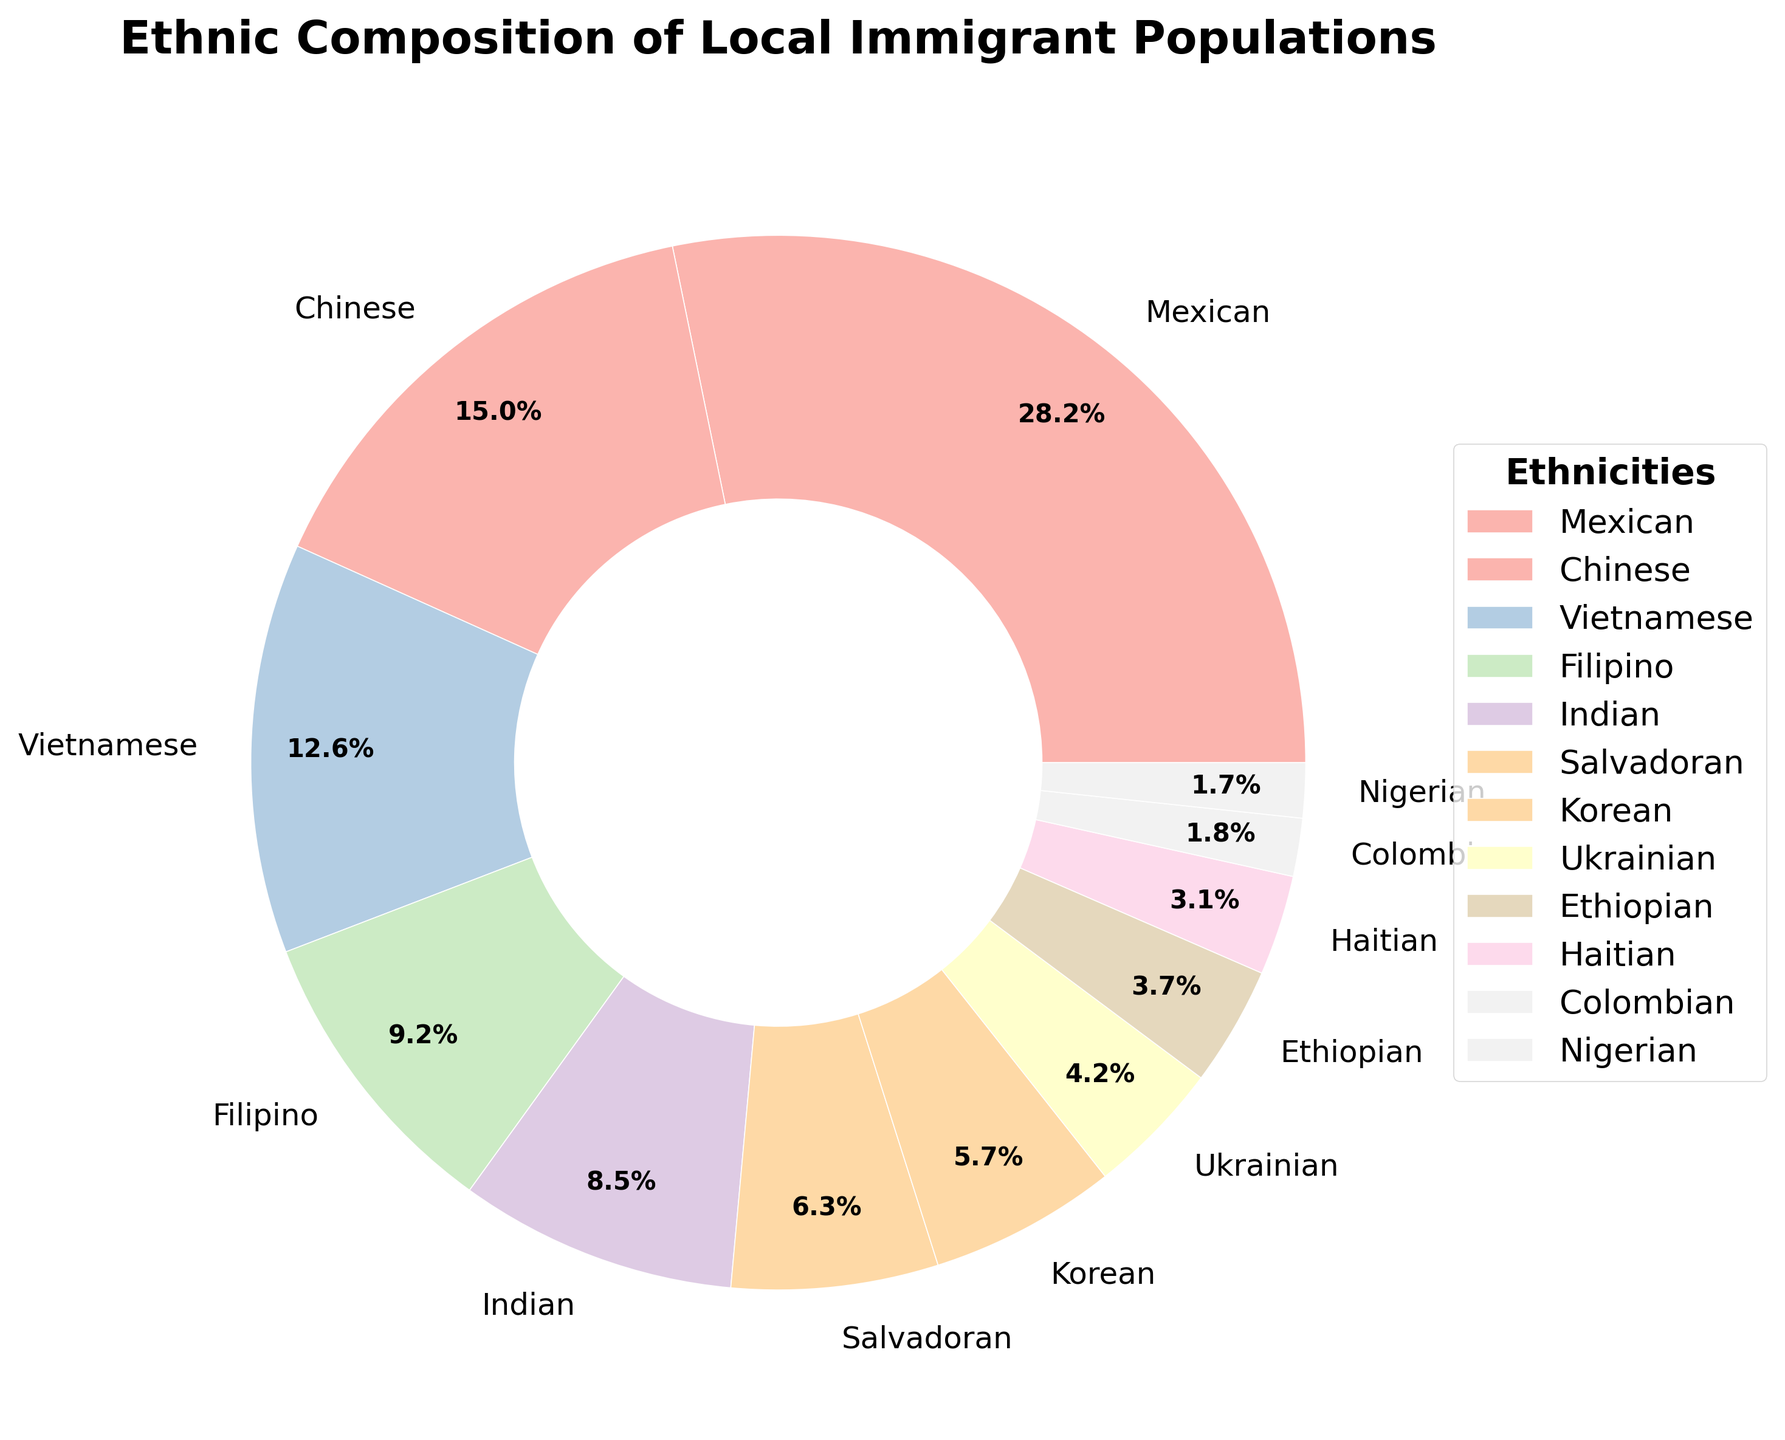What is the percentage for the largest ethnic group? The figure indicates that the largest segment in the pie chart corresponds to the Mexican ethnicity. By looking at the chart, the label shows that Mexicans constitute 28.5% of the local immigrant population.
Answer: 28.5% Which ethnic group has the smallest representation, and what is its percentage? The smallest segment in the pie chart corresponds to the Nigerian ethnicity. The label in the chart indicates that Nigerians make up 1.7% of the local immigrant population.
Answer: Nigerian, 1.7% How much more is the percentage of Chinese immigrants compared to Ukrainian immigrants? The label for Chinese immigrants shows 15.2%, and the label for Ukrainian immigrants shows 4.2%. Subtracting the percentage for Ukrainians from that of the Chinese gives 15.2% - 4.2% = 11%.
Answer: 11% Are Vietnamese and Filipino populations almost equal? By inspecting the pie chart, the percentages for Vietnamese and Filipino populations are 12.7% and 9.3% respectively. These percentages are relatively close but not equal.
Answer: No What is the combined percentage of Ethiopian and Haitian immigrants? The pie chart shows that Ethiopian immigrants constitute 3.7%, and Haitian immigrants make up 3.1%. Adding these gives 3.7% + 3.1% = 6.8%.
Answer: 6.8% Compare the Indian and Salvadoran immigrant populations and state which is larger. By looking at the pie chart, the segment for Indian immigrants shows 8.6%, and the Salvadoran segment shows 6.4%. The Indian immigrant population is larger than the Salvadoran population.
Answer: Indian What is the proportion of the top three ethnic groups relative to the total immigrant population? The top three ethnic groups on the pie chart are Mexican (28.5%), Chinese (15.2%), and Vietnamese (12.7%). Adding these percentages gives 28.5% + 15.2% + 12.7% = 56.4%.
Answer: 56.4% How many ethnic groups have a percentage below 5%? By inspecting the segments and labels, the ethnic groups below 5% are Ukrainian (4.2%), Ethiopian (3.7%), Haitian (3.1%), Colombian (1.8%), and Nigerian (1.7%). There are 5 such groups.
Answer: 5 Which groups are represented in the lightest colors, and could you identify their populations? In pie charts with pastel color schemes, typically lighter colors are used towards the lower percentage segments. The lightest colors are often near-white and pale shades used for smaller segments like Haitian and Nigerian populations. The labels show Haitians at 3.1% and Nigerians at 1.7%.
Answer: Haitian, Nigerian Among the ethnic groups listed, which two combined make up roughly one-quarter of the local immigrant population? By inspecting the pie chart, the two ethnic groups with percentages that add up close to a quarter (25%) of the total are Filipino (9.3%) and Indian (8.6%). Adding them gives 9.3% + 8.6% = 17.9%.
Answer: No two groups exactly make up one-quarter 